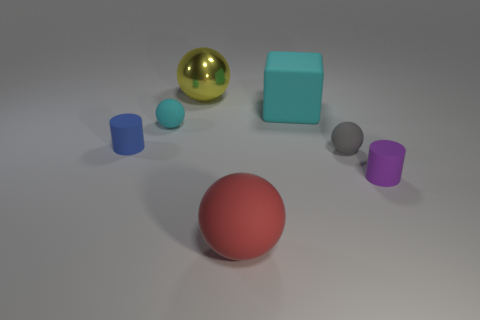Subtract all small gray spheres. How many spheres are left? 3 Add 2 cyan objects. How many objects exist? 9 Subtract all yellow spheres. How many spheres are left? 3 Subtract 2 balls. How many balls are left? 2 Add 6 large cyan objects. How many large cyan objects are left? 7 Add 3 big green rubber spheres. How many big green rubber spheres exist? 3 Subtract 1 yellow balls. How many objects are left? 6 Subtract all balls. How many objects are left? 3 Subtract all purple cylinders. Subtract all cyan spheres. How many cylinders are left? 1 Subtract all blue matte objects. Subtract all purple objects. How many objects are left? 5 